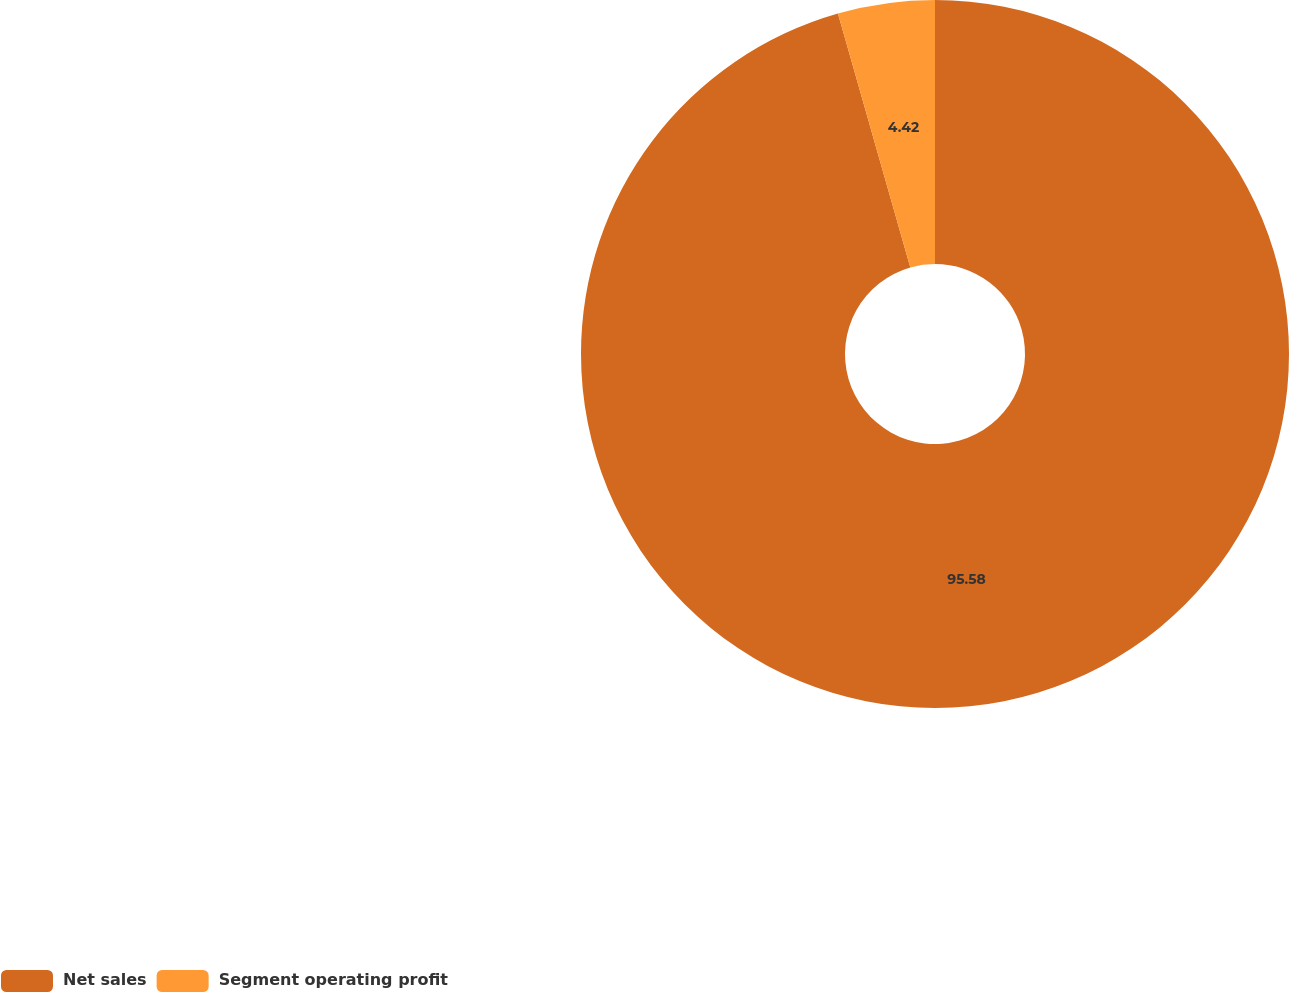<chart> <loc_0><loc_0><loc_500><loc_500><pie_chart><fcel>Net sales<fcel>Segment operating profit<nl><fcel>95.58%<fcel>4.42%<nl></chart> 